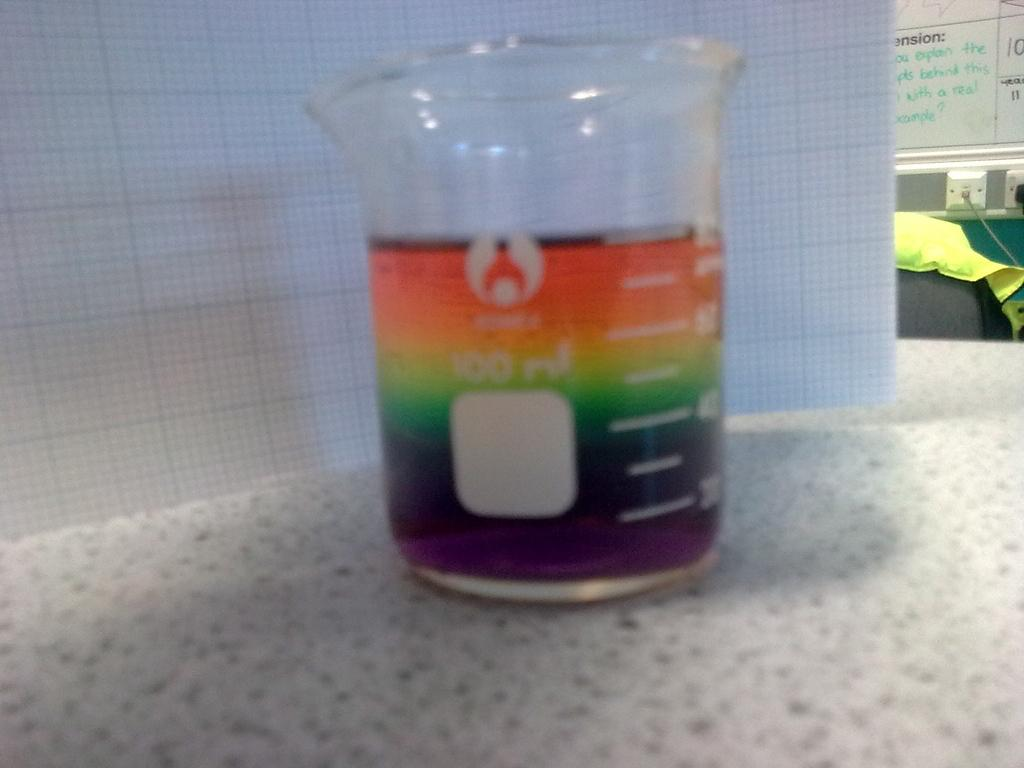<image>
Provide a brief description of the given image. A 100 ml beaker is filled with layers of different colored liquid. 